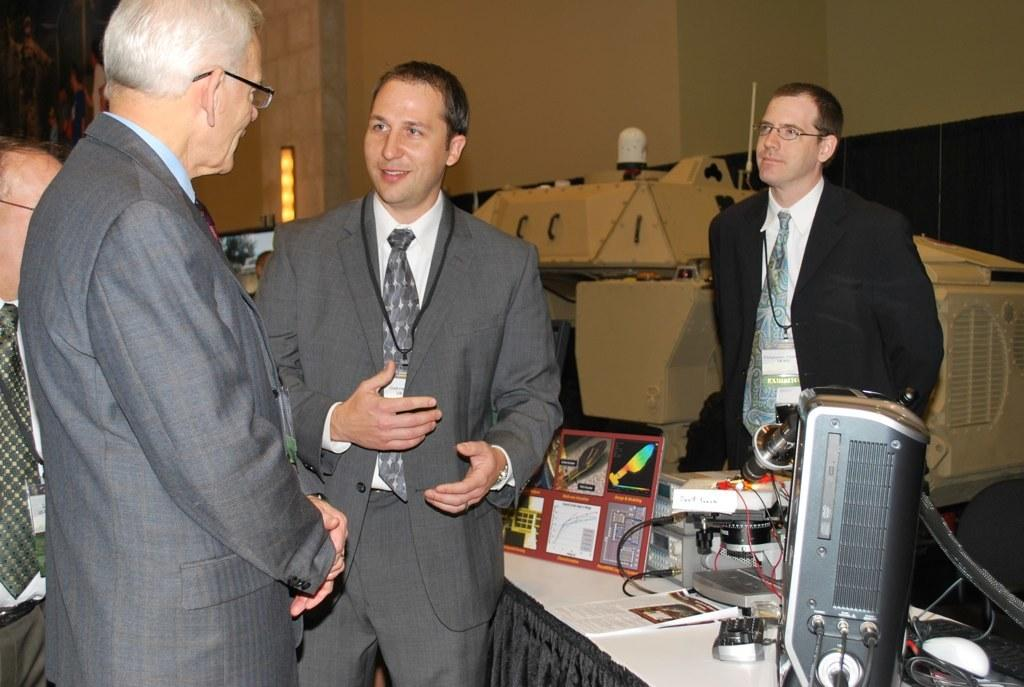What are the people in the image wearing? The people in the image are wearing suits. What are the people doing in the image? The people are standing. What objects can be seen on the table in the image? There are electronic devices on a table in the image. What can be seen in the background of the image? There is a wall visible in the background of the image. What type of hammer is being used to end the meeting in the image? There is no hammer or meeting present in the image. How are the people in the image caring for the electronic devices on the table? The image does not show the people interacting with the electronic devices, so it cannot be determined how they are caring for them. 